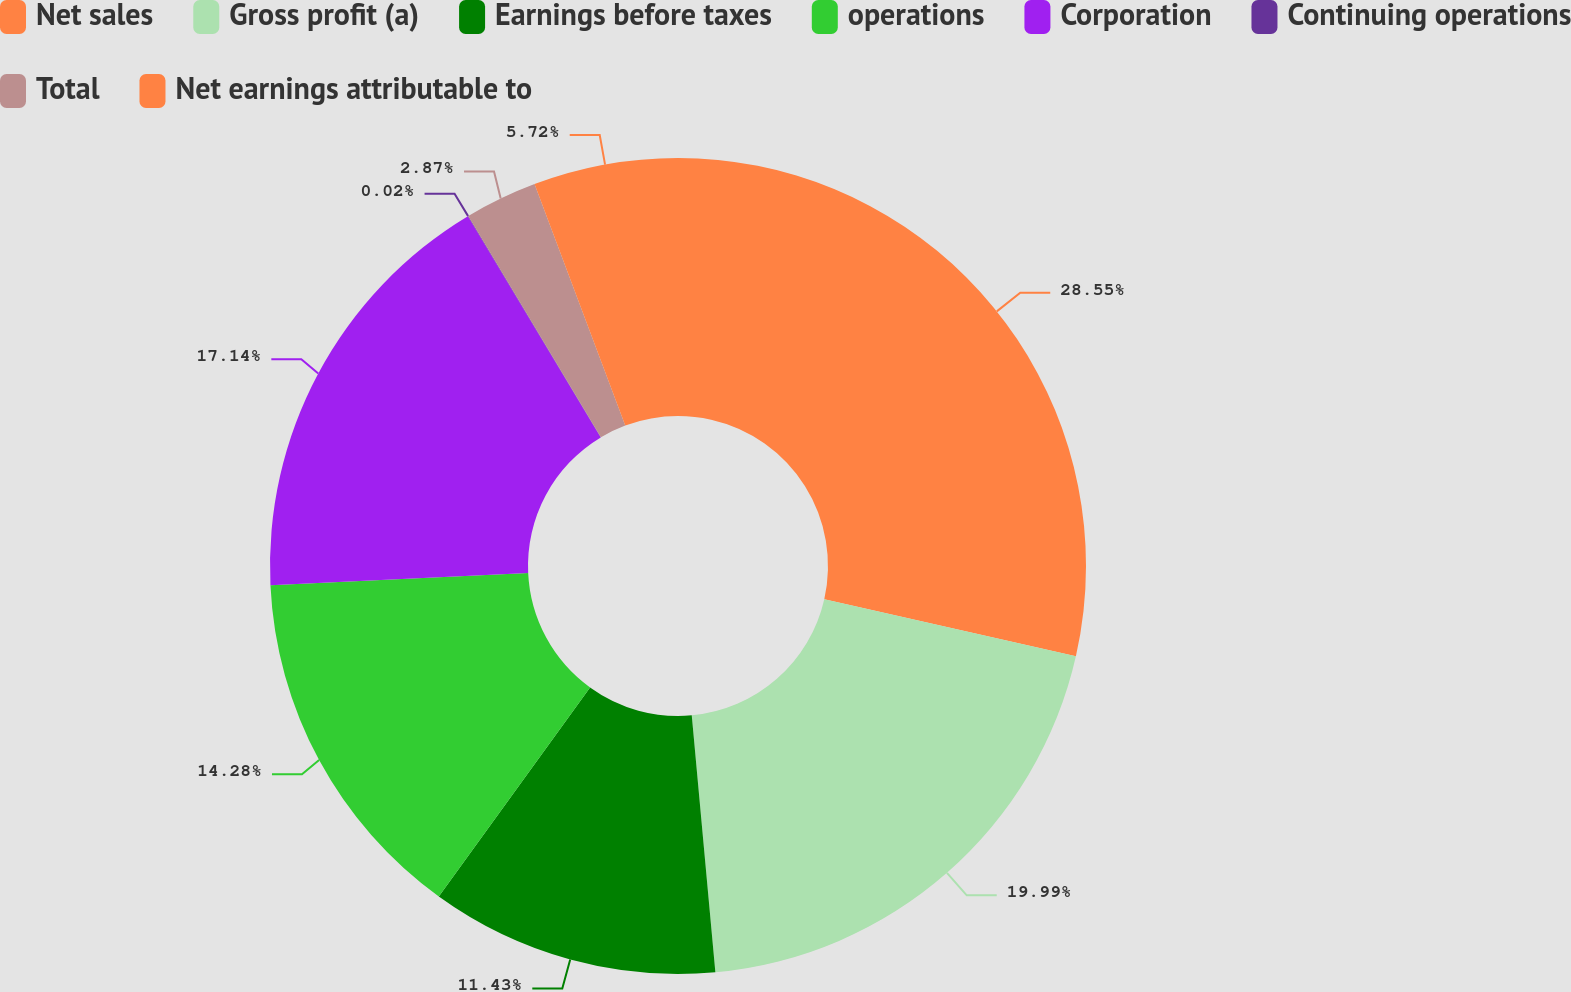<chart> <loc_0><loc_0><loc_500><loc_500><pie_chart><fcel>Net sales<fcel>Gross profit (a)<fcel>Earnings before taxes<fcel>operations<fcel>Corporation<fcel>Continuing operations<fcel>Total<fcel>Net earnings attributable to<nl><fcel>28.55%<fcel>19.99%<fcel>11.43%<fcel>14.28%<fcel>17.14%<fcel>0.02%<fcel>2.87%<fcel>5.72%<nl></chart> 